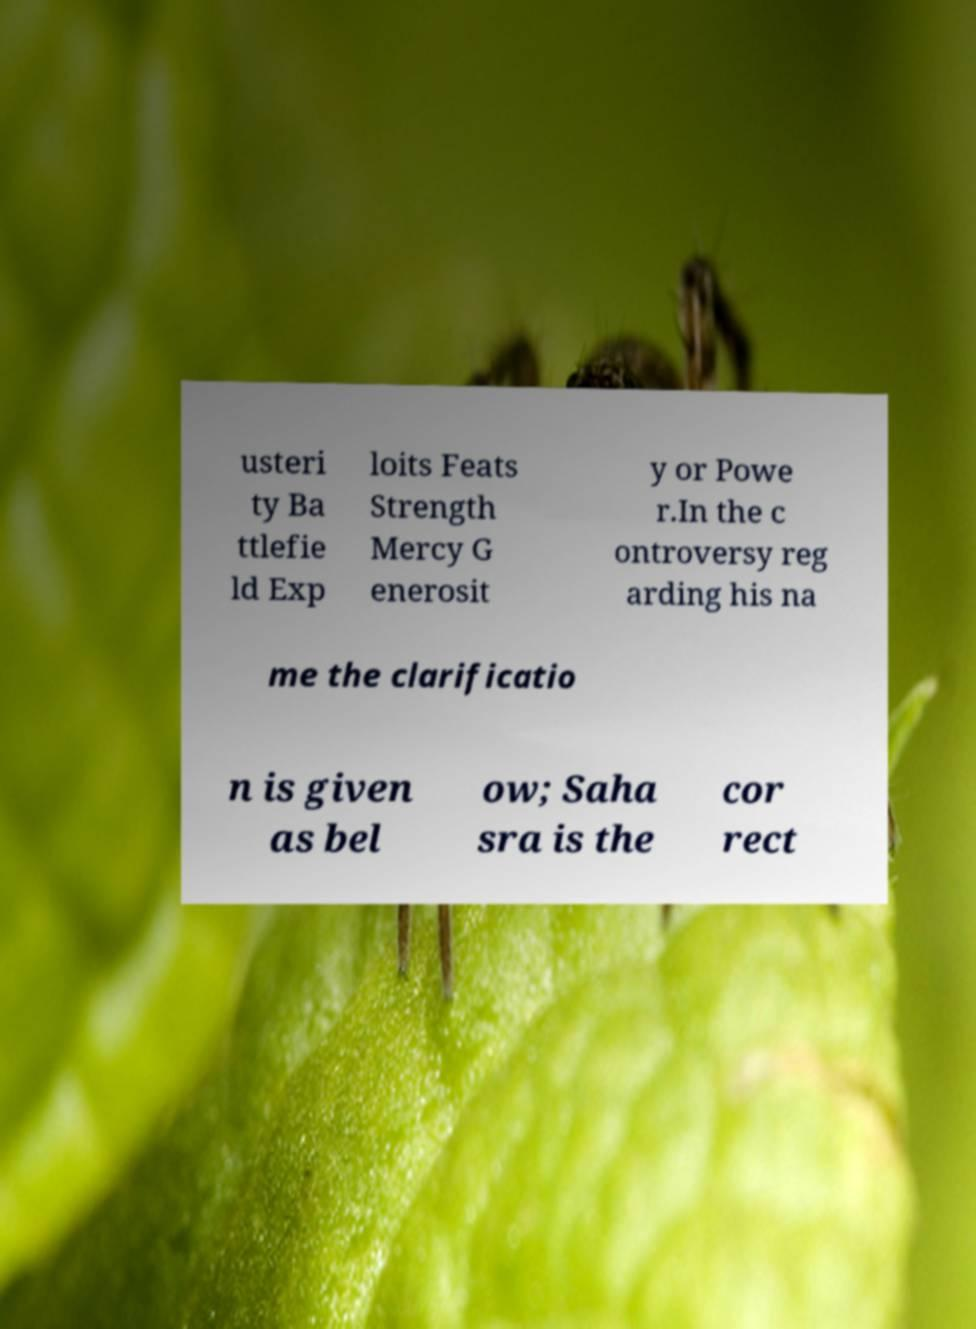Could you assist in decoding the text presented in this image and type it out clearly? usteri ty Ba ttlefie ld Exp loits Feats Strength Mercy G enerosit y or Powe r.In the c ontroversy reg arding his na me the clarificatio n is given as bel ow; Saha sra is the cor rect 